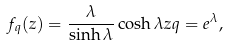Convert formula to latex. <formula><loc_0><loc_0><loc_500><loc_500>f _ { q } ( z ) = \frac { \lambda } { \sinh \lambda } \cosh \lambda z q = e ^ { \lambda } ,</formula> 